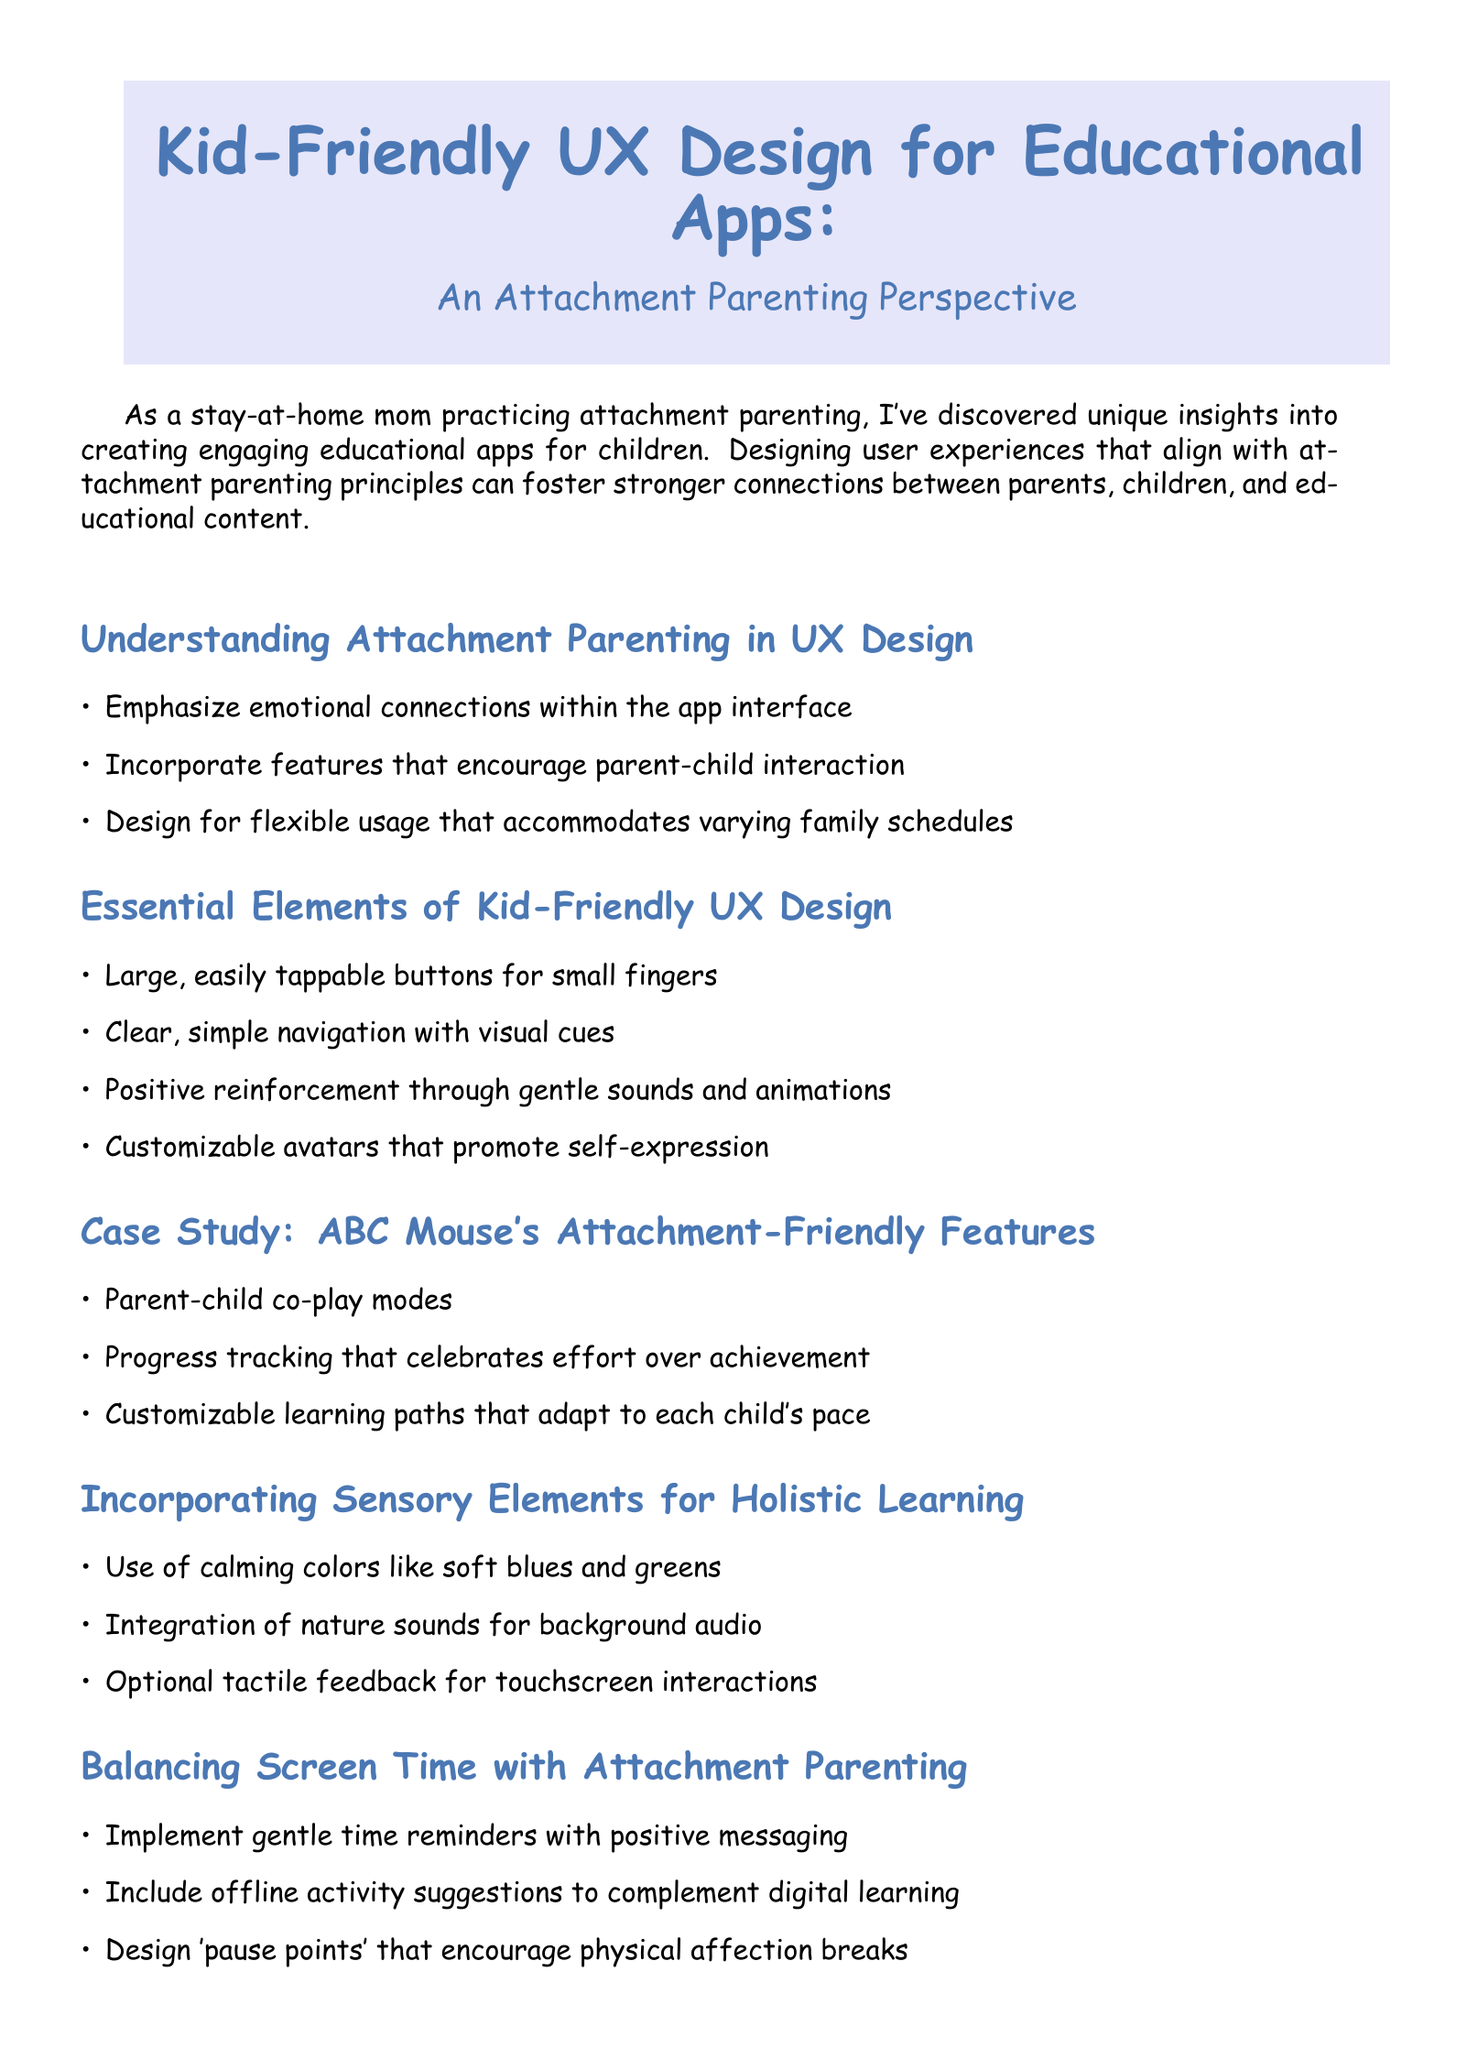what is the title of the newsletter? The title of the newsletter is mentioned at the beginning of the document.
Answer: Kid-Friendly UX Design for Educational Apps: An Attachment Parenting Perspective who is the author of the newsletter? The author is introduced at the end of the document with a brief biography.
Answer: Emily Parker how many essential elements of kid-friendly UX design are listed? The number of elements is specified in the corresponding section of the document.
Answer: Four what is one feature highlighted in ABC Mouse's case study? The case study mentions specific features that relate to attachment-friendly design.
Answer: Parent-child co-play modes what do the calming colors mentioned in the sensory elements section aim to achieve? The use of calming colors is described to enhance the learning environment.
Answer: Holistic learning what is the main focus of the practical application section? The practical application section outlines steps to design an educational game based on attachment principles.
Answer: Designing a Math Game with Attachment in Mind what type of feedback is suggested for touchscreen interactions? The document provides specific suggestions for enhancing user experience with sensory elements.
Answer: Tactile feedback what key principle does Dr. Sarah Thompson emphasize regarding educational apps? The expert quote summarizes a significant sentiment regarding app design and parenting principles.
Answer: Nurturing digital environment 